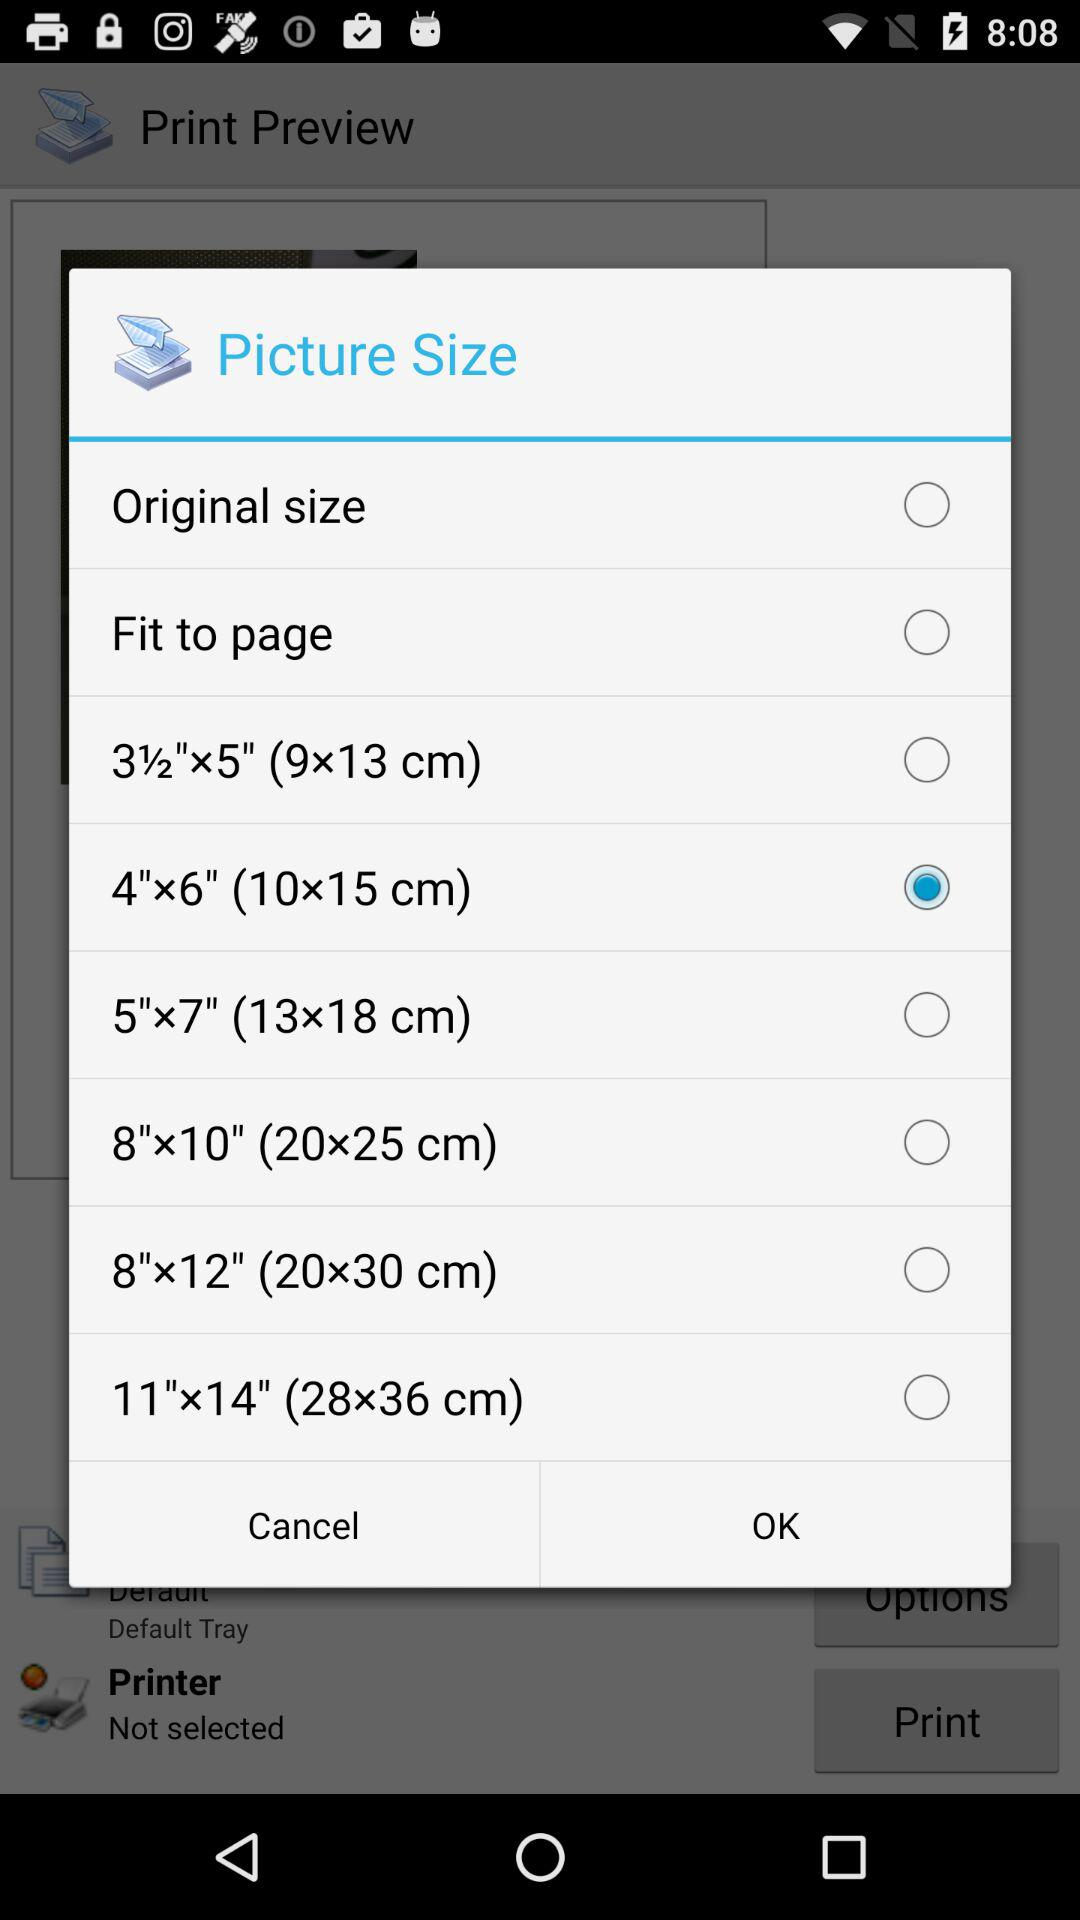Which picture size is not selected? The unselected picture sizes are "Original size", "Fit to page", "3½"x5" (9x13 cm)", "5"x7" (13x18 cm)", "8"x10" (20x25 cm)", "8"x12" (20x30 cm)" and "11"x14" (28x36 cm)". 